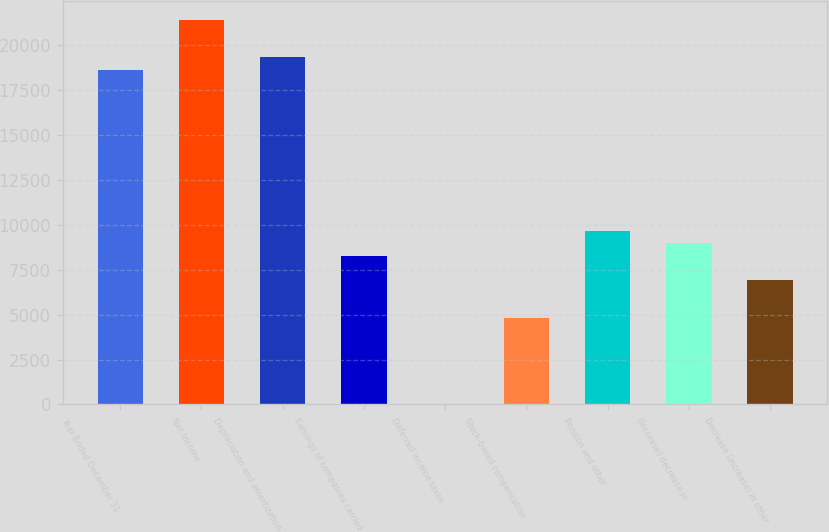<chart> <loc_0><loc_0><loc_500><loc_500><bar_chart><fcel>Year Ended December 31<fcel>Net Income<fcel>Depreciation and amortization<fcel>Earnings of companies carried<fcel>Deferred income taxes<fcel>Stock-based compensation<fcel>Pension and other<fcel>(Increase) decrease in<fcel>Decrease (increase) in other<nl><fcel>18617.1<fcel>21374.3<fcel>19306.4<fcel>8277.6<fcel>6<fcel>4831.1<fcel>9656.2<fcel>8966.9<fcel>6899<nl></chart> 